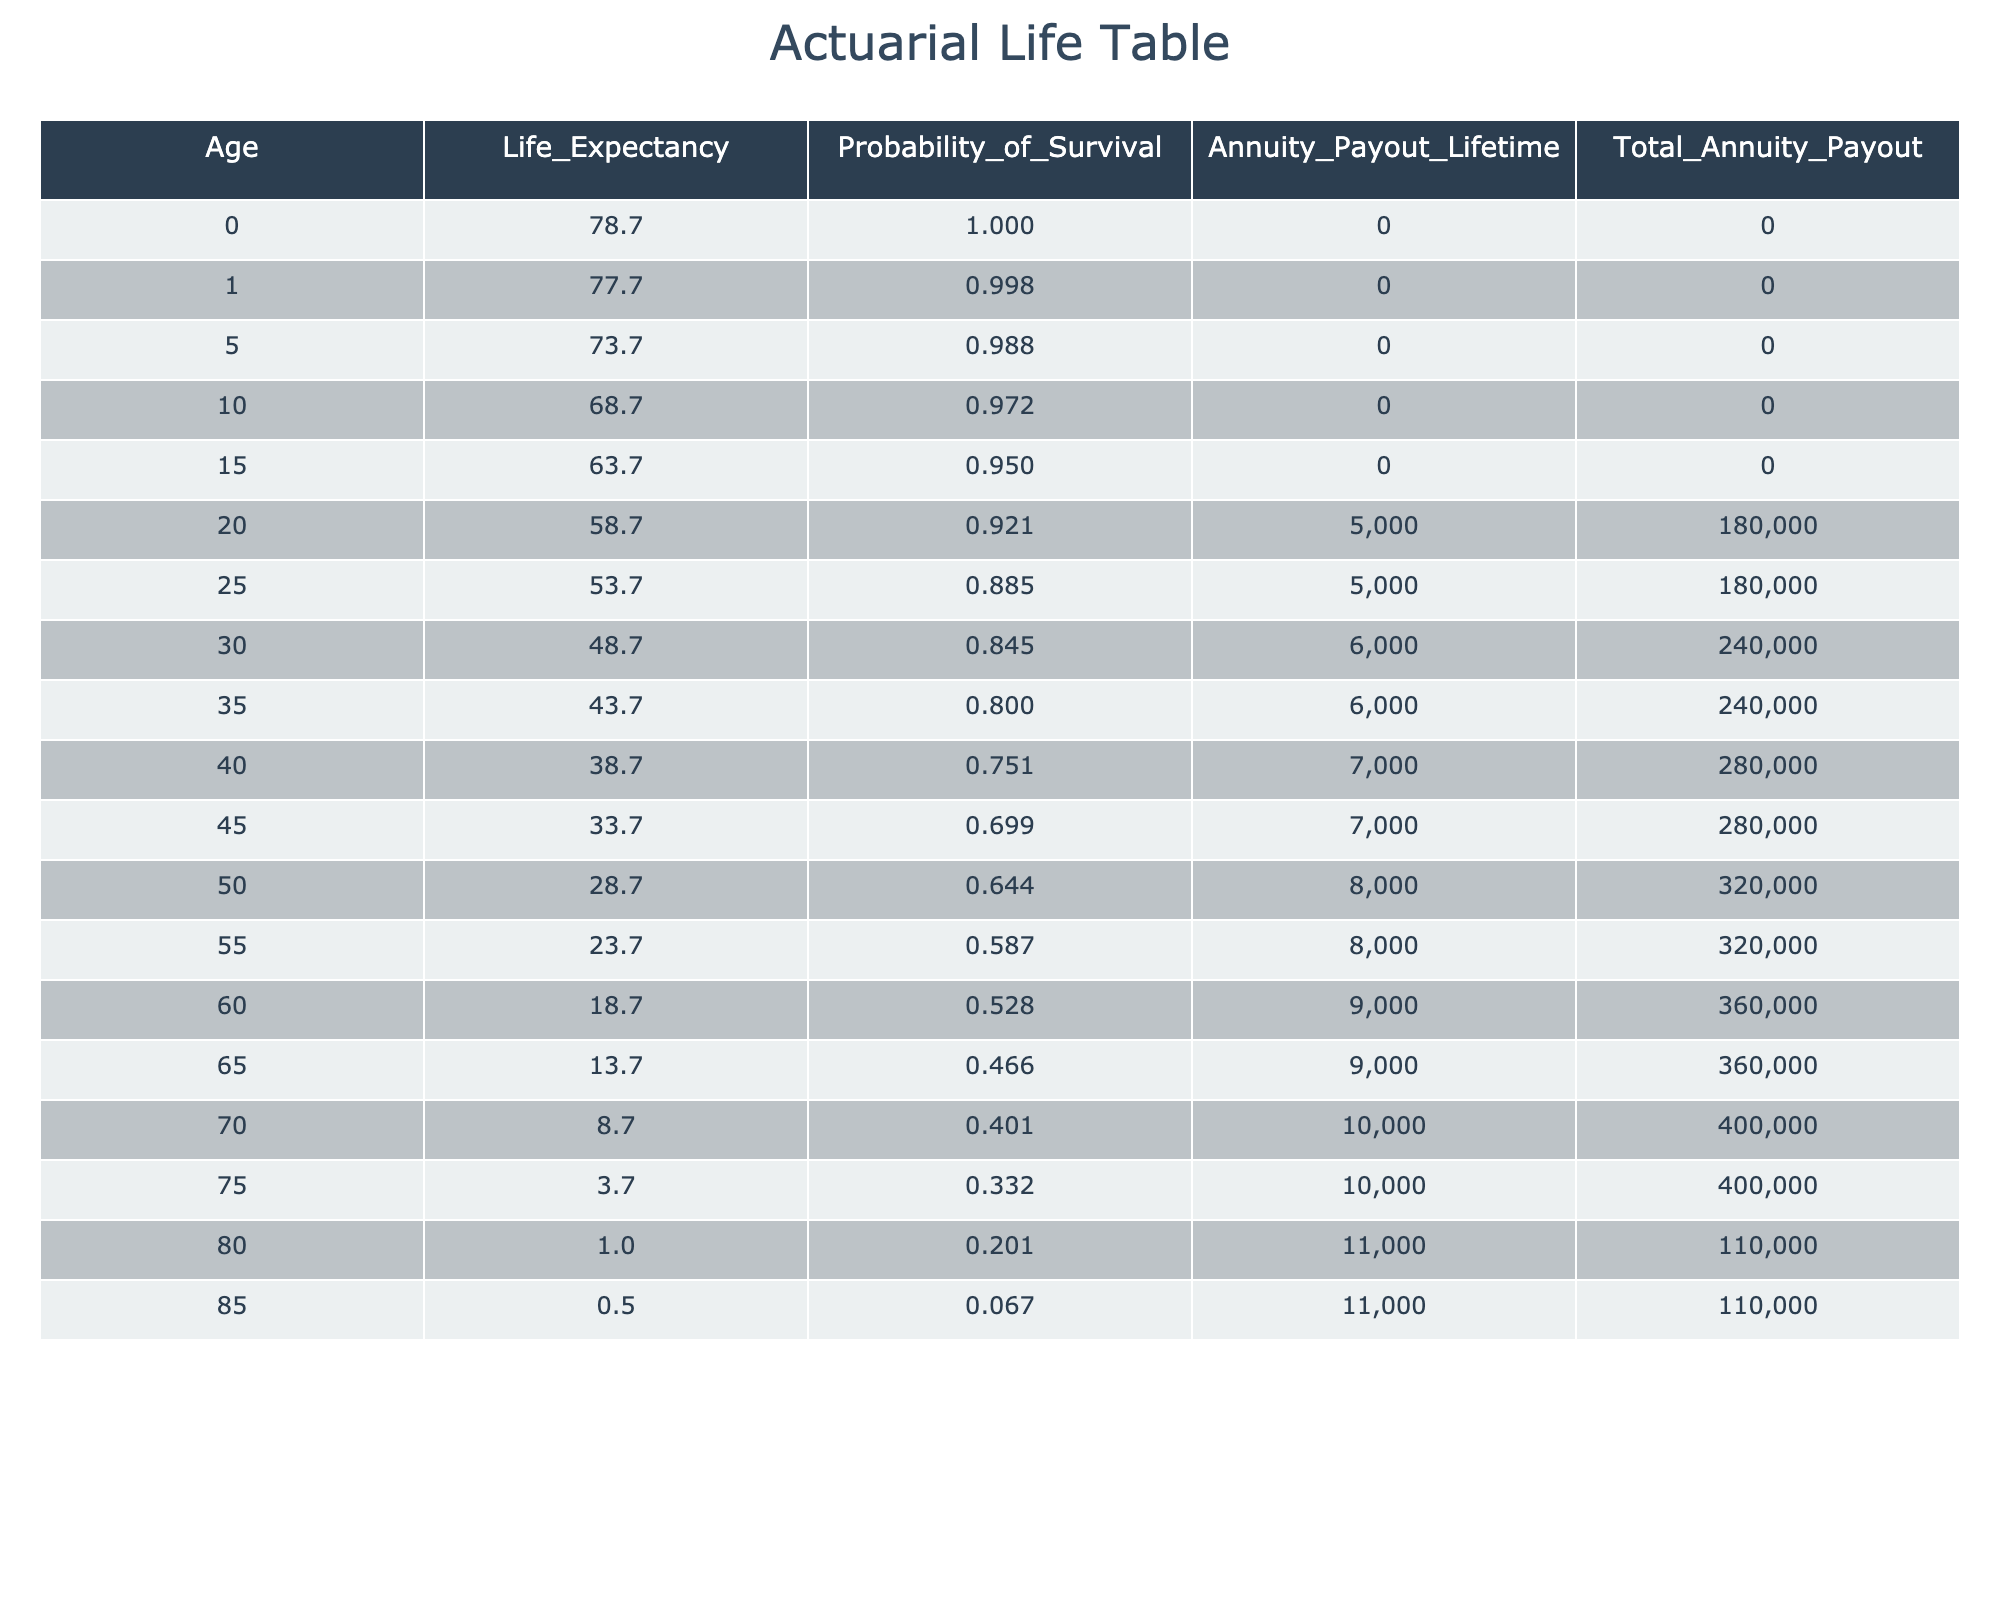What is the life expectancy at age 60? According to the table, the life expectancy at age 60 is listed as 18.7 years.
Answer: 18.7 What is the annuity payout for someone aged 35? The annuity payout for an individual at age 35 is 6000.
Answer: 6000 Is the total annuity payout increasing with age? It is not true that the total annuity payout is consistently increasing with age; for instance, from ages 20 to 25, the total payout remains 180000, despite the increase in age.
Answer: No What is the probability of survival for someone aged 80? The table indicates that the probability of survival at age 80 is 0.201.
Answer: 0.201 What is the average total annuity payout for individuals aged 20 to 40? To find this, we take the total annuity payouts for ages 20 (180000), 25 (180000), 30 (240000), 35 (240000), and 40 (280000), giving a sum of 1120000. There are 5 age points, so the average is 1120000/5 = 224000.
Answer: 224000 What is the total annuity payout at age 75 compared to age 85? The total annuity payout at age 75 is 400000, while at age 85 it is 110000. Thus, the total payout at age 75 is significantly higher than at age 85.
Answer: 400000 vs 110000 What is the difference in life expectancy between age 70 and age 80? The life expectancy at age 70 is 8.7 years, and at age 80 it is 1.0 years. Therefore, the difference in life expectancy is 8.7 - 1.0 = 7.7 years.
Answer: 7.7 Do individuals aged 60 and above have higher annuity payouts than those aged 50 and below? It is true that individuals aged 60 and above have higher annuity payouts, as they are receiving payouts amounting to 9000 or 10000, while those aged 50 and below receive amounts that are lower.
Answer: Yes What is the total annuity payout sum for all ages below 35? For all ages below 35, the total annuity payouts are 0 (ages 0 to 15) + 180000 (age 20) + 180000 (age 25) + 240000 (age 30) + 240000 (age 35), giving a total of 840000.
Answer: 840000 